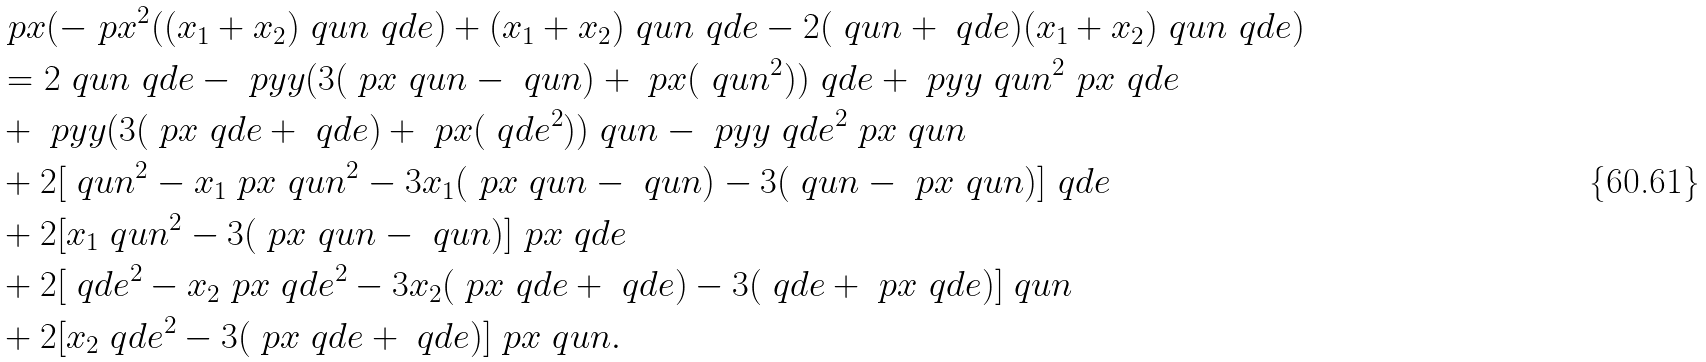<formula> <loc_0><loc_0><loc_500><loc_500>& \ p x ( - \ p x ^ { 2 } ( ( x _ { 1 } + x _ { 2 } ) \ q u n \ q d e ) + ( x _ { 1 } + x _ { 2 } ) \ q u n \ q d e - 2 ( \ q u n + \ q d e ) ( x _ { 1 } + x _ { 2 } ) \ q u n \ q d e ) \\ & = 2 \ q u n \ q d e - \ p y y ( 3 ( \ p x \ q u n - \ q u n ) + \ p x ( \ q u n ^ { 2 } ) ) \ q d e + \ p y y \ q u n ^ { 2 } \ p x \ q d e \\ & + \ p y y ( 3 ( \ p x \ q d e + \ q d e ) + \ p x ( \ q d e ^ { 2 } ) ) \ q u n - \ p y y \ q d e ^ { 2 } \ p x \ q u n \\ & + 2 [ \ q u n ^ { 2 } - x _ { 1 } \ p x \ q u n ^ { 2 } - 3 x _ { 1 } ( \ p x \ q u n - \ q u n ) - 3 ( \ q u n - \ p x \ q u n ) ] \ q d e \\ & + 2 [ x _ { 1 } \ q u n ^ { 2 } - 3 ( \ p x \ q u n - \ q u n ) ] \ p x \ q d e \\ & + 2 [ \ q d e ^ { 2 } - x _ { 2 } \ p x \ q d e ^ { 2 } - 3 x _ { 2 } ( \ p x \ q d e + \ q d e ) - 3 ( \ q d e + \ p x \ q d e ) ] \ q u n \\ & + 2 [ x _ { 2 } \ q d e ^ { 2 } - 3 ( \ p x \ q d e + \ q d e ) ] \ p x \ q u n .</formula> 